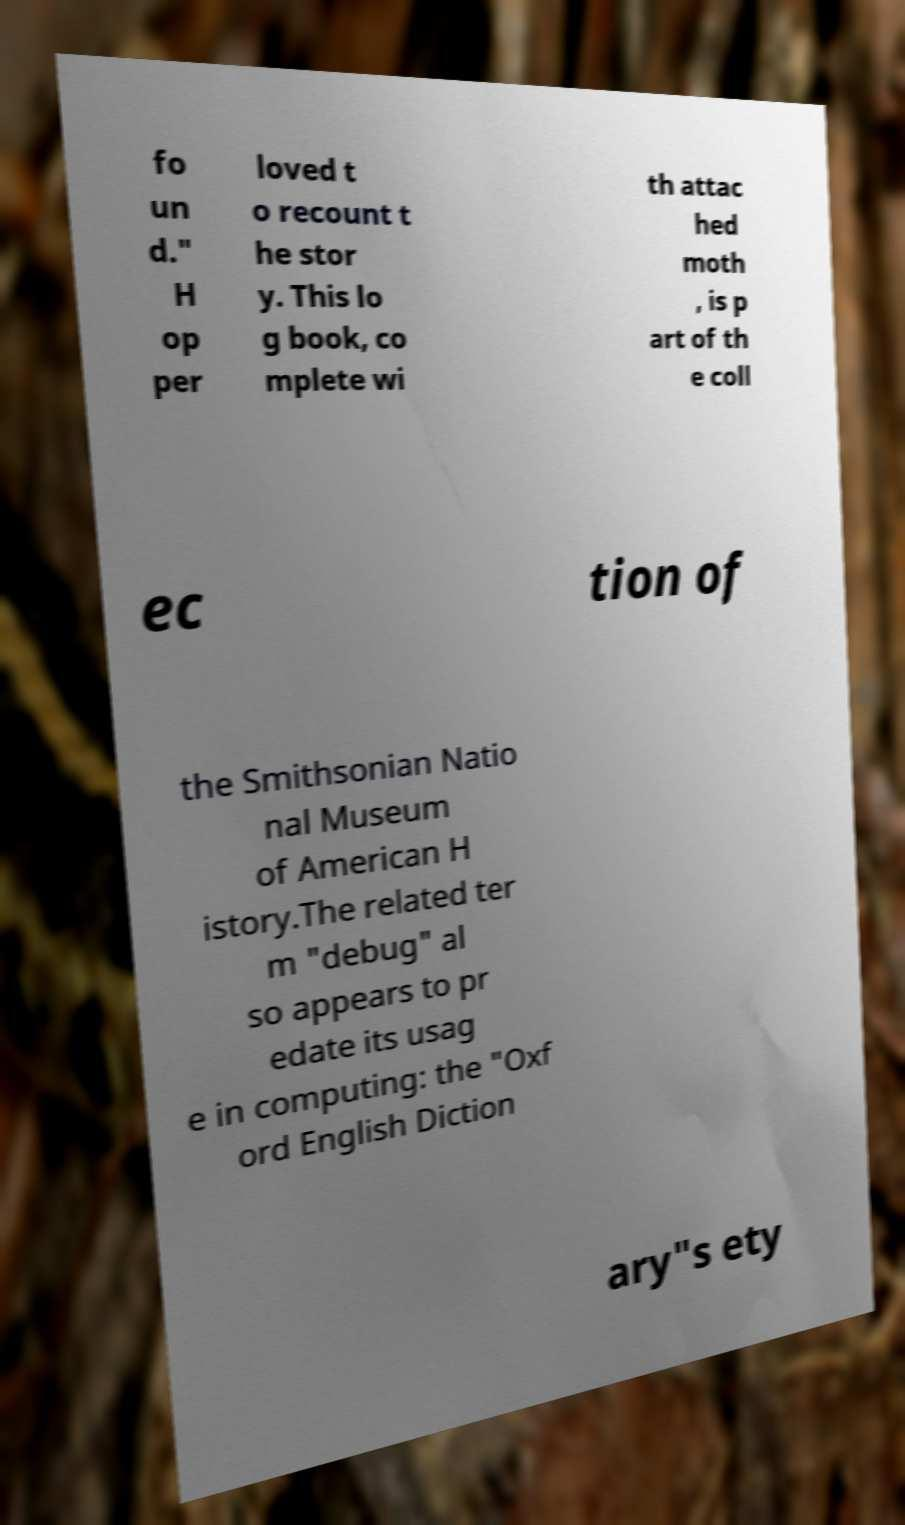What messages or text are displayed in this image? I need them in a readable, typed format. fo un d." H op per loved t o recount t he stor y. This lo g book, co mplete wi th attac hed moth , is p art of th e coll ec tion of the Smithsonian Natio nal Museum of American H istory.The related ter m "debug" al so appears to pr edate its usag e in computing: the "Oxf ord English Diction ary"s ety 